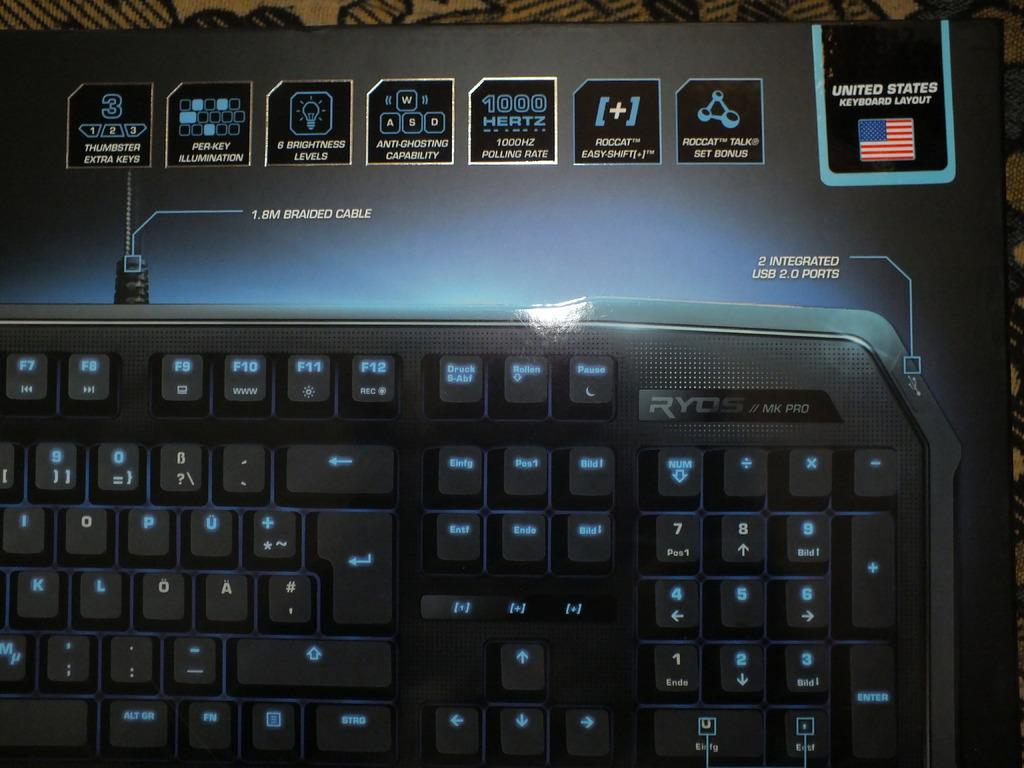<image>
Present a compact description of the photo's key features. RYOS MK Pro keyboard in united states keyboard layout 